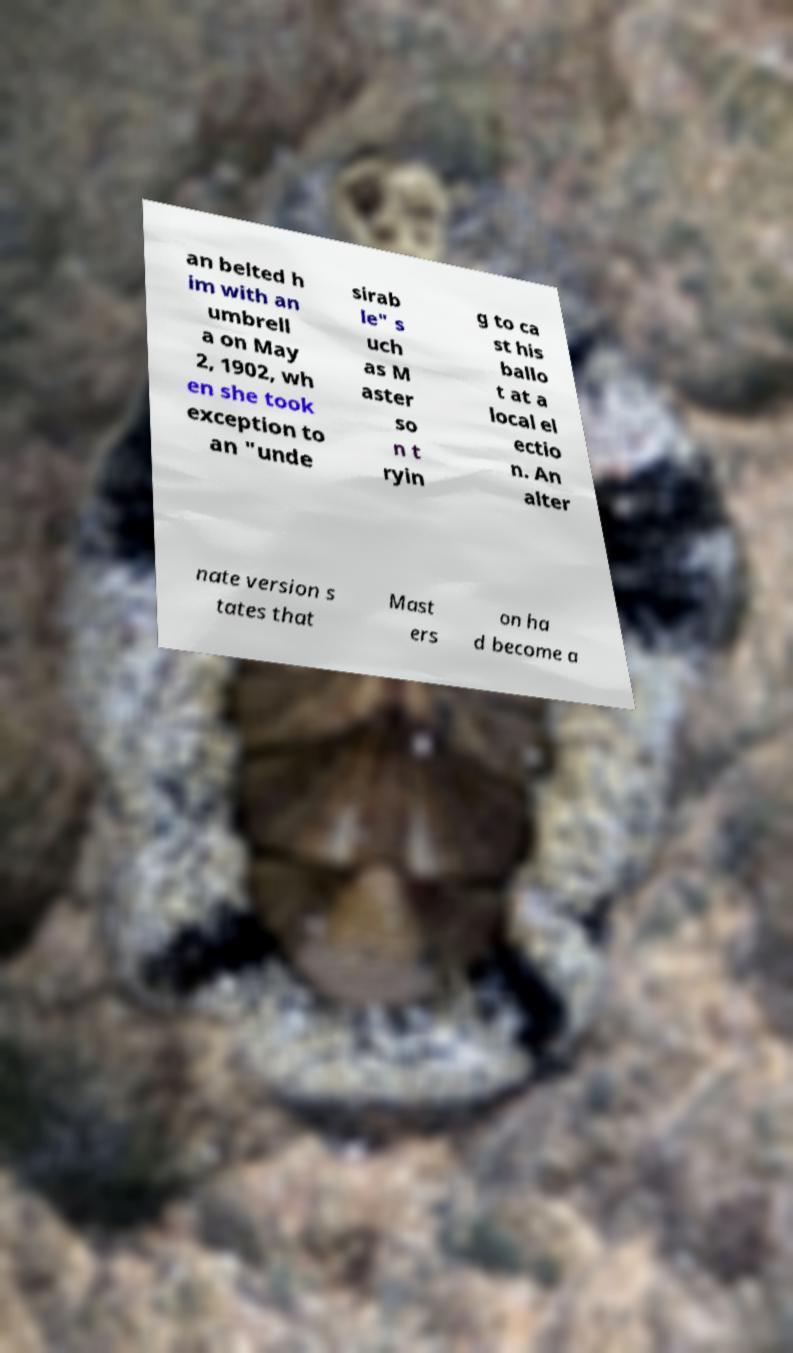What messages or text are displayed in this image? I need them in a readable, typed format. an belted h im with an umbrell a on May 2, 1902, wh en she took exception to an "unde sirab le" s uch as M aster so n t ryin g to ca st his ballo t at a local el ectio n. An alter nate version s tates that Mast ers on ha d become a 